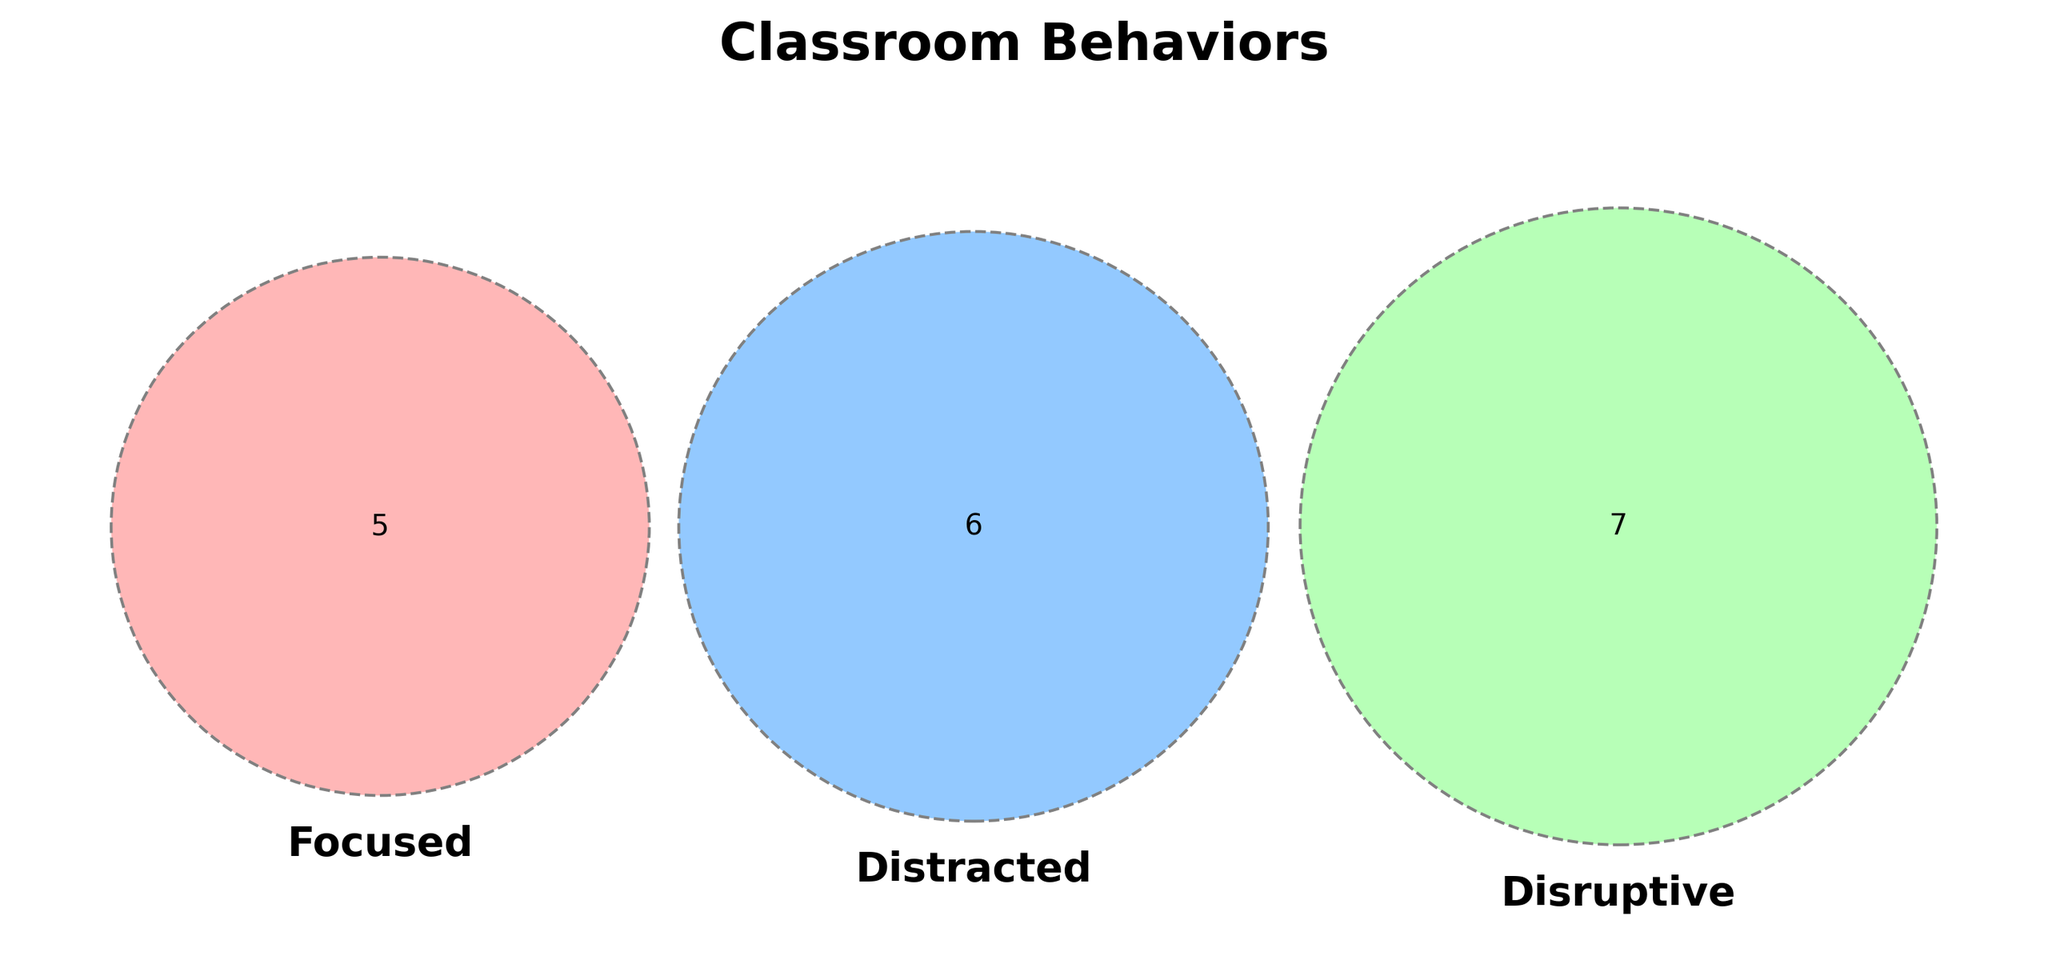What is the title of the Venn diagram? The title of the diagram is usually above the Venn circles. The title states what the diagram is about.
Answer: Classroom Behaviors What behavior is only found in the focused category? Look inside the segment labeled "Focused" which does not overlap with any of the other categories. These are behaviors that are exclusively focused.
Answer: Raising hands, Taking notes, Answering questions, Completing assignments, Group discussions Which behavior is common to both distracted and disruptive categories but not to the focused category? Look at the portions of the Venn diagram where the distracted and disruptive circles overlap without intersecting with the focused circle.
Answer: Whispering to friends How many behaviors are included in the disruptive category? Count all behaviors listed in the disruptive circle, including those that intersect with other circles.
Answer: 7 behaviors Which category has the most number of unique behaviors? Count the number of behaviors in each circle that does not overlap with others and compare them.
Answer: Focused Is there any behavior that is common to all three categories (focused, distracted, disruptive)? Look at the center part where all three circles intersect to check if it contains any behavior.
Answer: No Which behaviors are found in both the focused and distracted categories but not in the disruptive category? Look at the intersection between the focused and distracted circles excluding the disruptive circle intersections.
Answer: There are none Which category has the least number of unique behaviors? Count the number of behaviors in each circle that does not overlap with others and compare them.
Answer: Distracted What behaviors overlap between disruptive and focused categories but not distracted? Look at the segment where the focused and disruptive circles overlap excluding the distracted circle.
Answer: There are none 